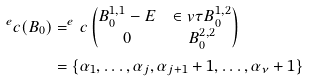<formula> <loc_0><loc_0><loc_500><loc_500>^ { e } c ( B _ { 0 } ) & = ^ { e } c \begin{pmatrix} B ^ { 1 , 1 } _ { 0 } - E & \in v \tau B ^ { 1 , 2 } _ { 0 } \\ 0 & B ^ { 2 , 2 } _ { 0 } \end{pmatrix} \\ & = \{ \alpha _ { 1 } , \dots , \alpha _ { j } , \alpha _ { j + 1 } + 1 , \dots , \alpha _ { \nu } + 1 \}</formula> 